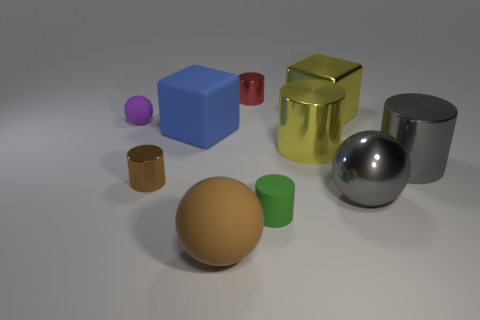Subtract all matte spheres. How many spheres are left? 1 Subtract 2 cylinders. How many cylinders are left? 3 Subtract all blue blocks. How many blocks are left? 1 Subtract all blocks. How many objects are left? 8 Add 7 matte cylinders. How many matte cylinders are left? 8 Add 5 blue cubes. How many blue cubes exist? 6 Subtract 0 cyan cubes. How many objects are left? 10 Subtract all cyan cylinders. Subtract all cyan blocks. How many cylinders are left? 5 Subtract all purple metal spheres. Subtract all small metal cylinders. How many objects are left? 8 